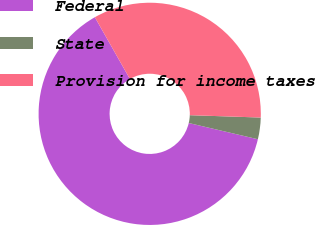<chart> <loc_0><loc_0><loc_500><loc_500><pie_chart><fcel>Federal<fcel>State<fcel>Provision for income taxes<nl><fcel>63.12%<fcel>3.14%<fcel>33.75%<nl></chart> 